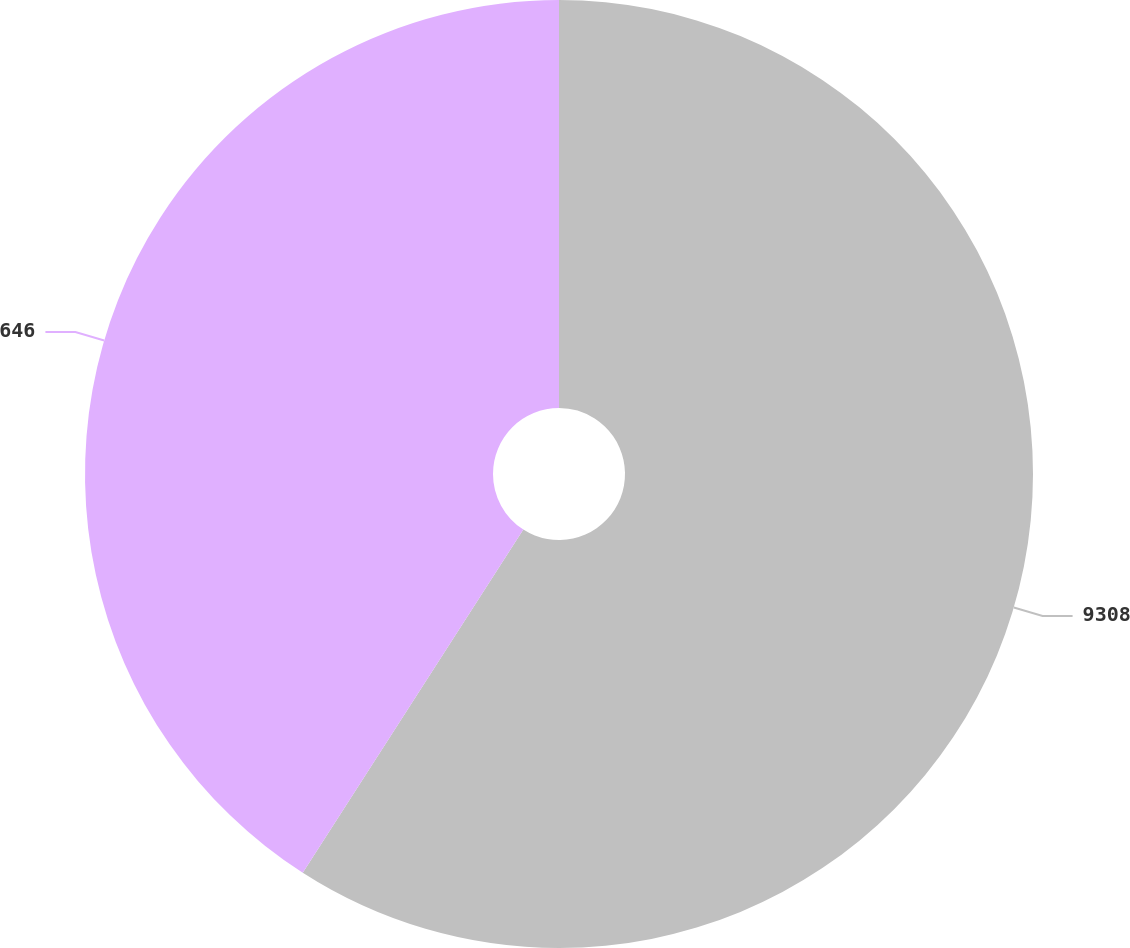<chart> <loc_0><loc_0><loc_500><loc_500><pie_chart><fcel>9308<fcel>646<nl><fcel>59.09%<fcel>40.91%<nl></chart> 